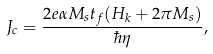<formula> <loc_0><loc_0><loc_500><loc_500>J _ { c } = \frac { 2 e \alpha M _ { s } t _ { f } ( H _ { k } + 2 \pi M _ { s } ) } { \hbar { \eta } } ,</formula> 